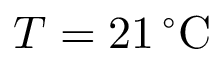<formula> <loc_0><loc_0><loc_500><loc_500>T = 2 1 \, ^ { \circ } C</formula> 